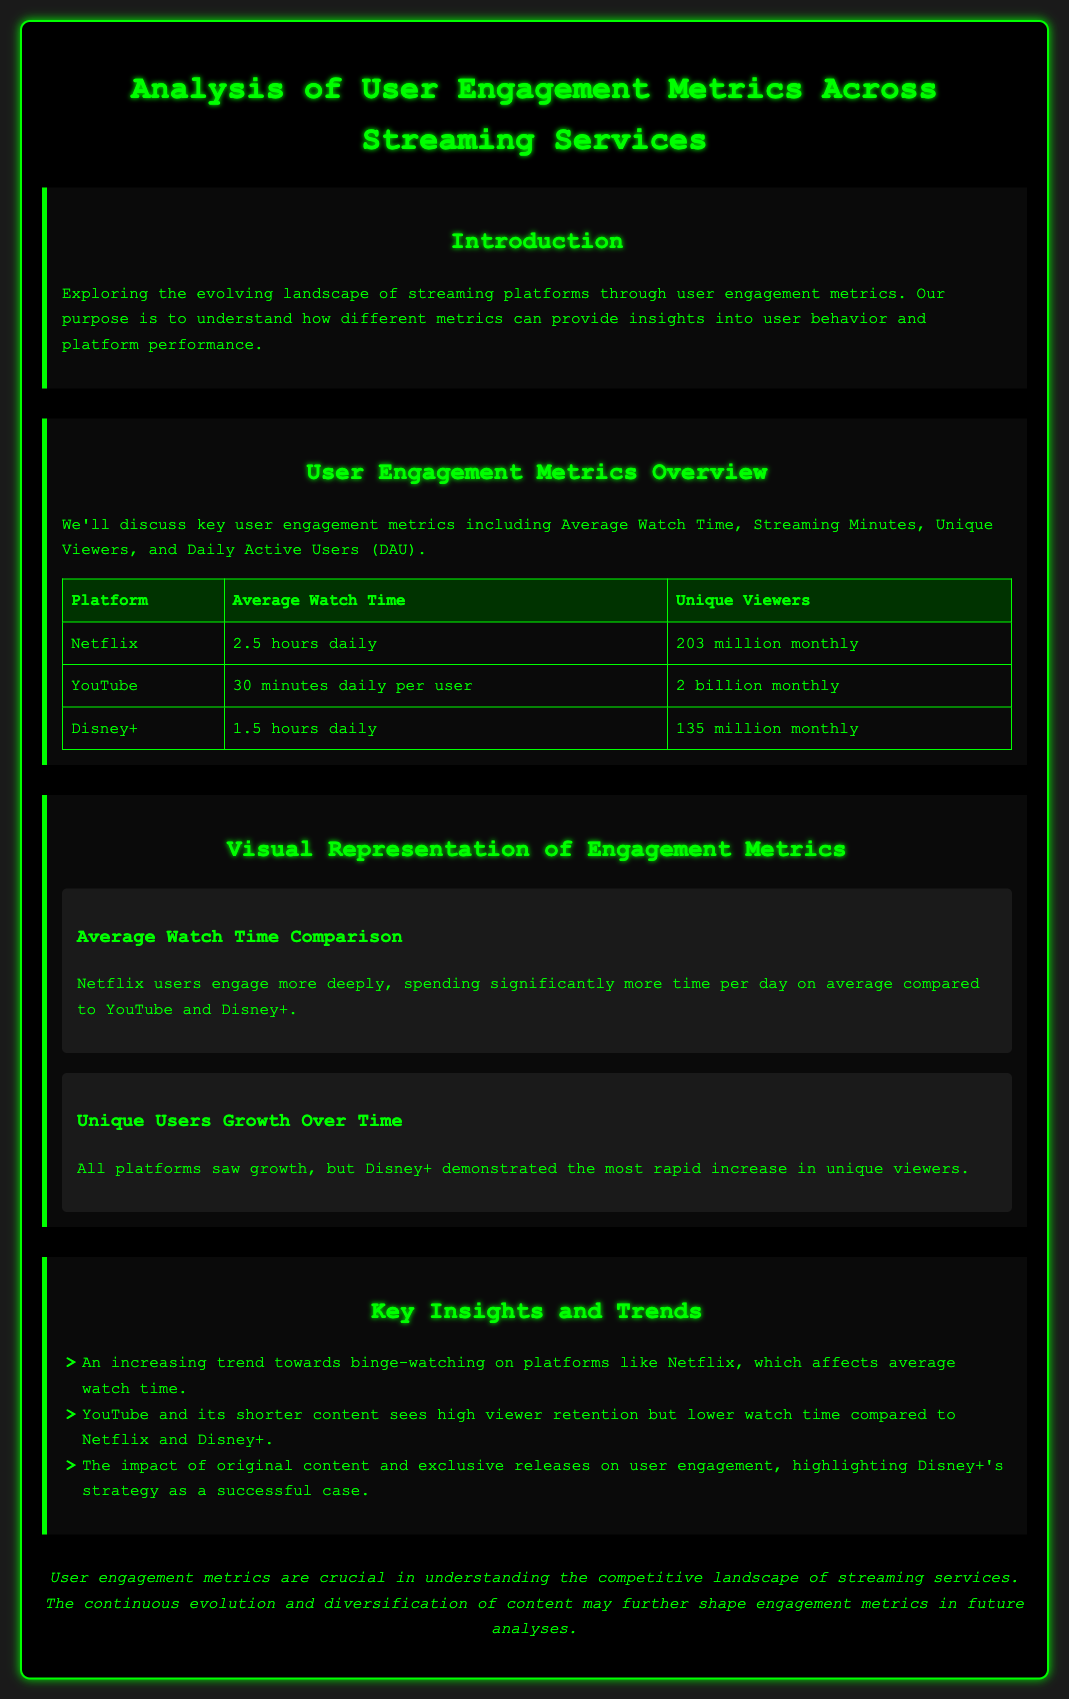What is the average watch time for Netflix? According to the document, Netflix has an average watch time of 2.5 hours daily.
Answer: 2.5 hours daily How many unique viewers does YouTube have monthly? The document states that YouTube has 2 billion unique viewers monthly.
Answer: 2 billion Which platform showed the most rapid increase in unique viewers? The document highlights that Disney+ demonstrated the most rapid increase in unique viewers.
Answer: Disney+ What trend is observed in Netflix's average watch time? The document notes an increasing trend towards binge-watching on Netflix, affecting its average watch time.
Answer: Binge-watching What percentage of the user engagement section discusses key insights and trends? The section on insights and trends contains three bullet points, showcasing critical insights into user behavior across platforms.
Answer: Three bullet points 